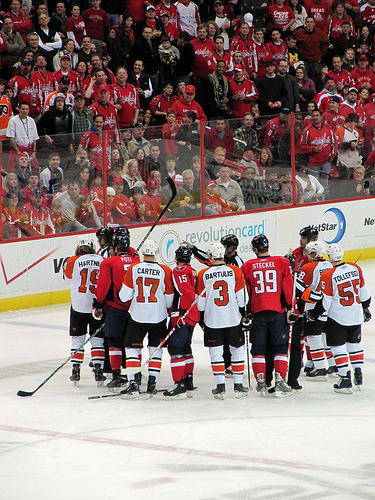<image>
Is the players on the playground? Yes. Looking at the image, I can see the players is positioned on top of the playground, with the playground providing support. Where is the jersey in relation to the man? Is it on the man? No. The jersey is not positioned on the man. They may be near each other, but the jersey is not supported by or resting on top of the man. Is the helmet on the man? No. The helmet is not positioned on the man. They may be near each other, but the helmet is not supported by or resting on top of the man. Where is the white jersey in relation to the red jersey? Is it next to the red jersey? Yes. The white jersey is positioned adjacent to the red jersey, located nearby in the same general area. 